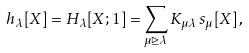<formula> <loc_0><loc_0><loc_500><loc_500>h _ { \lambda } [ X ] = H _ { \lambda } [ X ; 1 ] = \sum _ { \mu \unrhd \lambda } K _ { \mu \lambda } \, s _ { \mu } [ X ] \, ,</formula> 